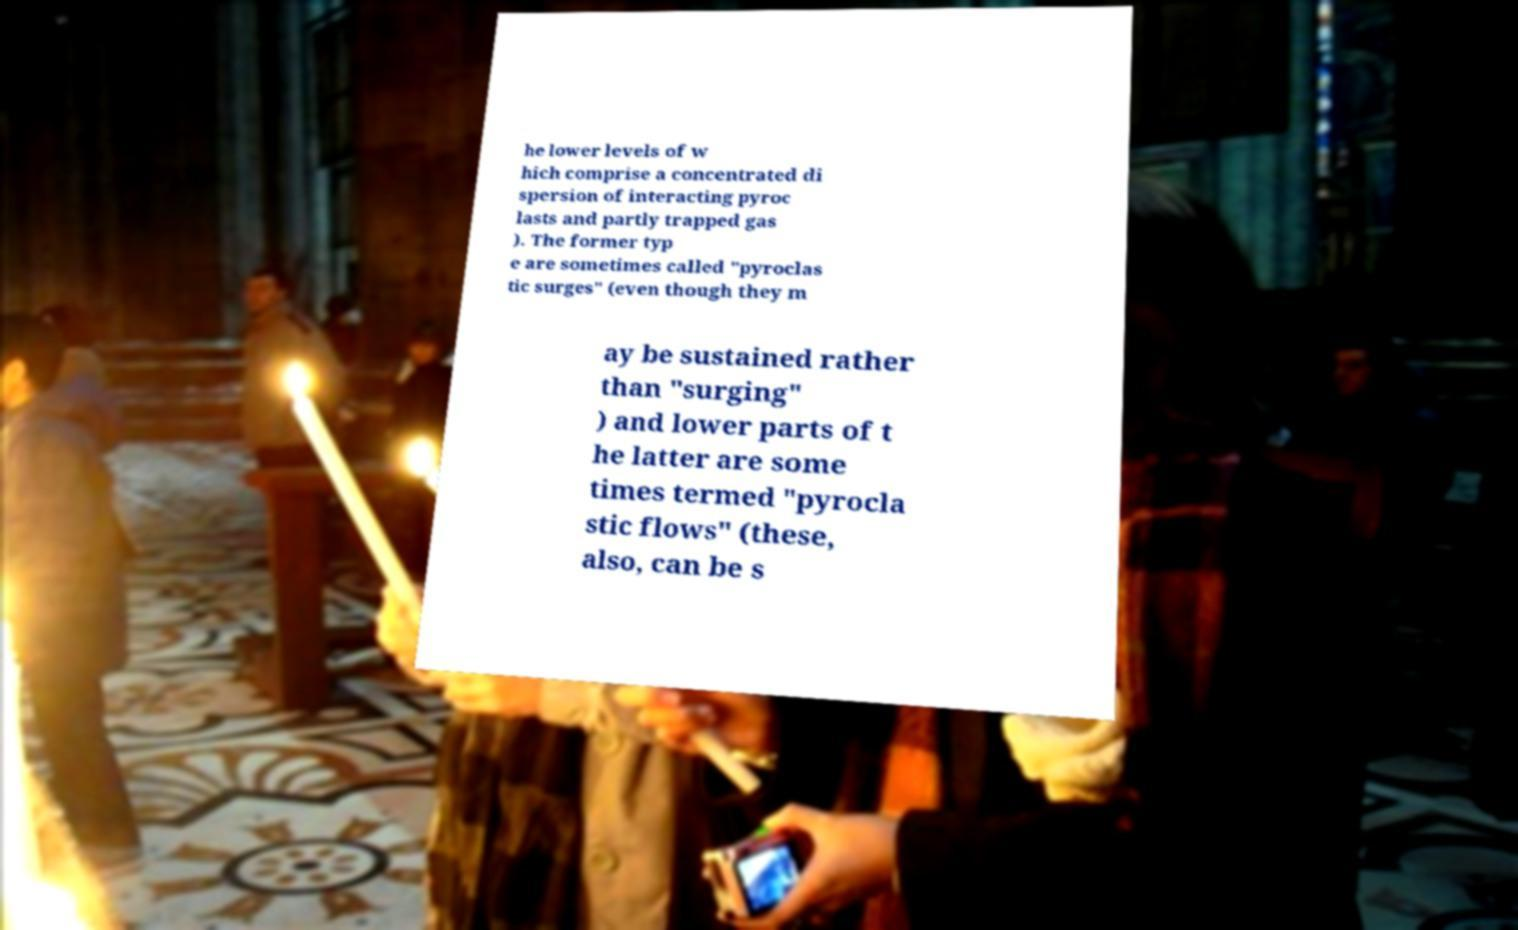Please identify and transcribe the text found in this image. he lower levels of w hich comprise a concentrated di spersion of interacting pyroc lasts and partly trapped gas ). The former typ e are sometimes called "pyroclas tic surges" (even though they m ay be sustained rather than "surging" ) and lower parts of t he latter are some times termed "pyrocla stic flows" (these, also, can be s 